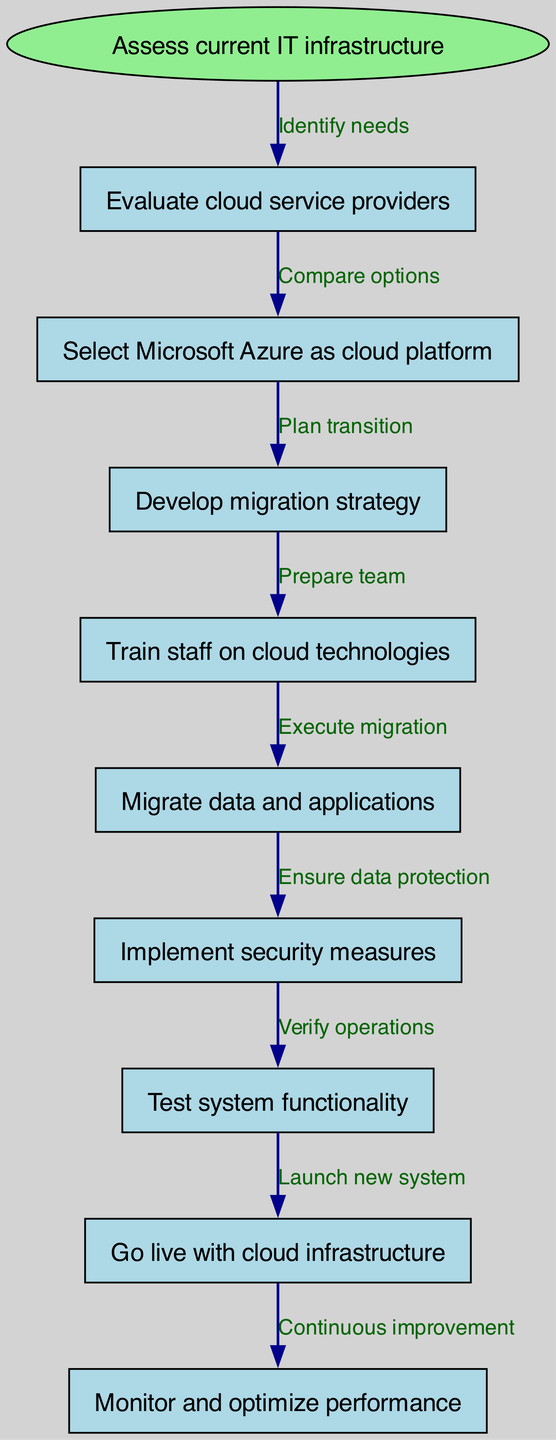What is the starting point of the clinical pathway? The starting point is identified in the diagram as "Assess current IT infrastructure", which serves as the initial step for the transition process.
Answer: Assess current IT infrastructure How many nodes are there in the clinical pathway? By counting the nodes listed in the diagram, there are a total of 9 nodes, including the starting point.
Answer: 9 What is the label for the edge from "Select Microsoft Azure as cloud platform" to "Develop migration strategy"? The label on this edge describes the action taken between the two nodes, which is "Plan transition”.
Answer: Plan transition Which node follows "Implement security measures"? According to the flow of the diagram, the node that comes after "Implement security measures" is "Test system functionality".
Answer: Test system functionality What is the last step in the clinical pathway? The final step in the diagram is represented as "Monitor and optimize performance", which indicates ongoing maintenance after implementation.
Answer: Monitor and optimize performance What action is taken after "Train staff on cloud technologies"? The action that follows this node is "Migrate data and applications", showing that training comes before the actual migration execution.
Answer: Migrate data and applications How do you go from "Go live with cloud infrastructure" to "Monitor and optimize performance"? The transition from these two nodes is labeled as "Continuous improvement", emphasizing that performance monitoring is an ongoing task after going live.
Answer: Continuous improvement In total, how many edges are there in the clinical pathway? By counting the labeled connections between the nodes, we find there are 8 edges in the diagram.
Answer: 8 What node directly follows "Develop migration strategy"? The node that immediately follows this node in the pathway is "Train staff on cloud technologies", indicating the next necessary step in the process.
Answer: Train staff on cloud technologies 